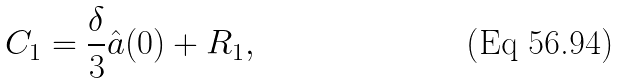Convert formula to latex. <formula><loc_0><loc_0><loc_500><loc_500>C _ { 1 } = \frac { \delta } { 3 } \hat { a } ( 0 ) + R _ { 1 } ,</formula> 